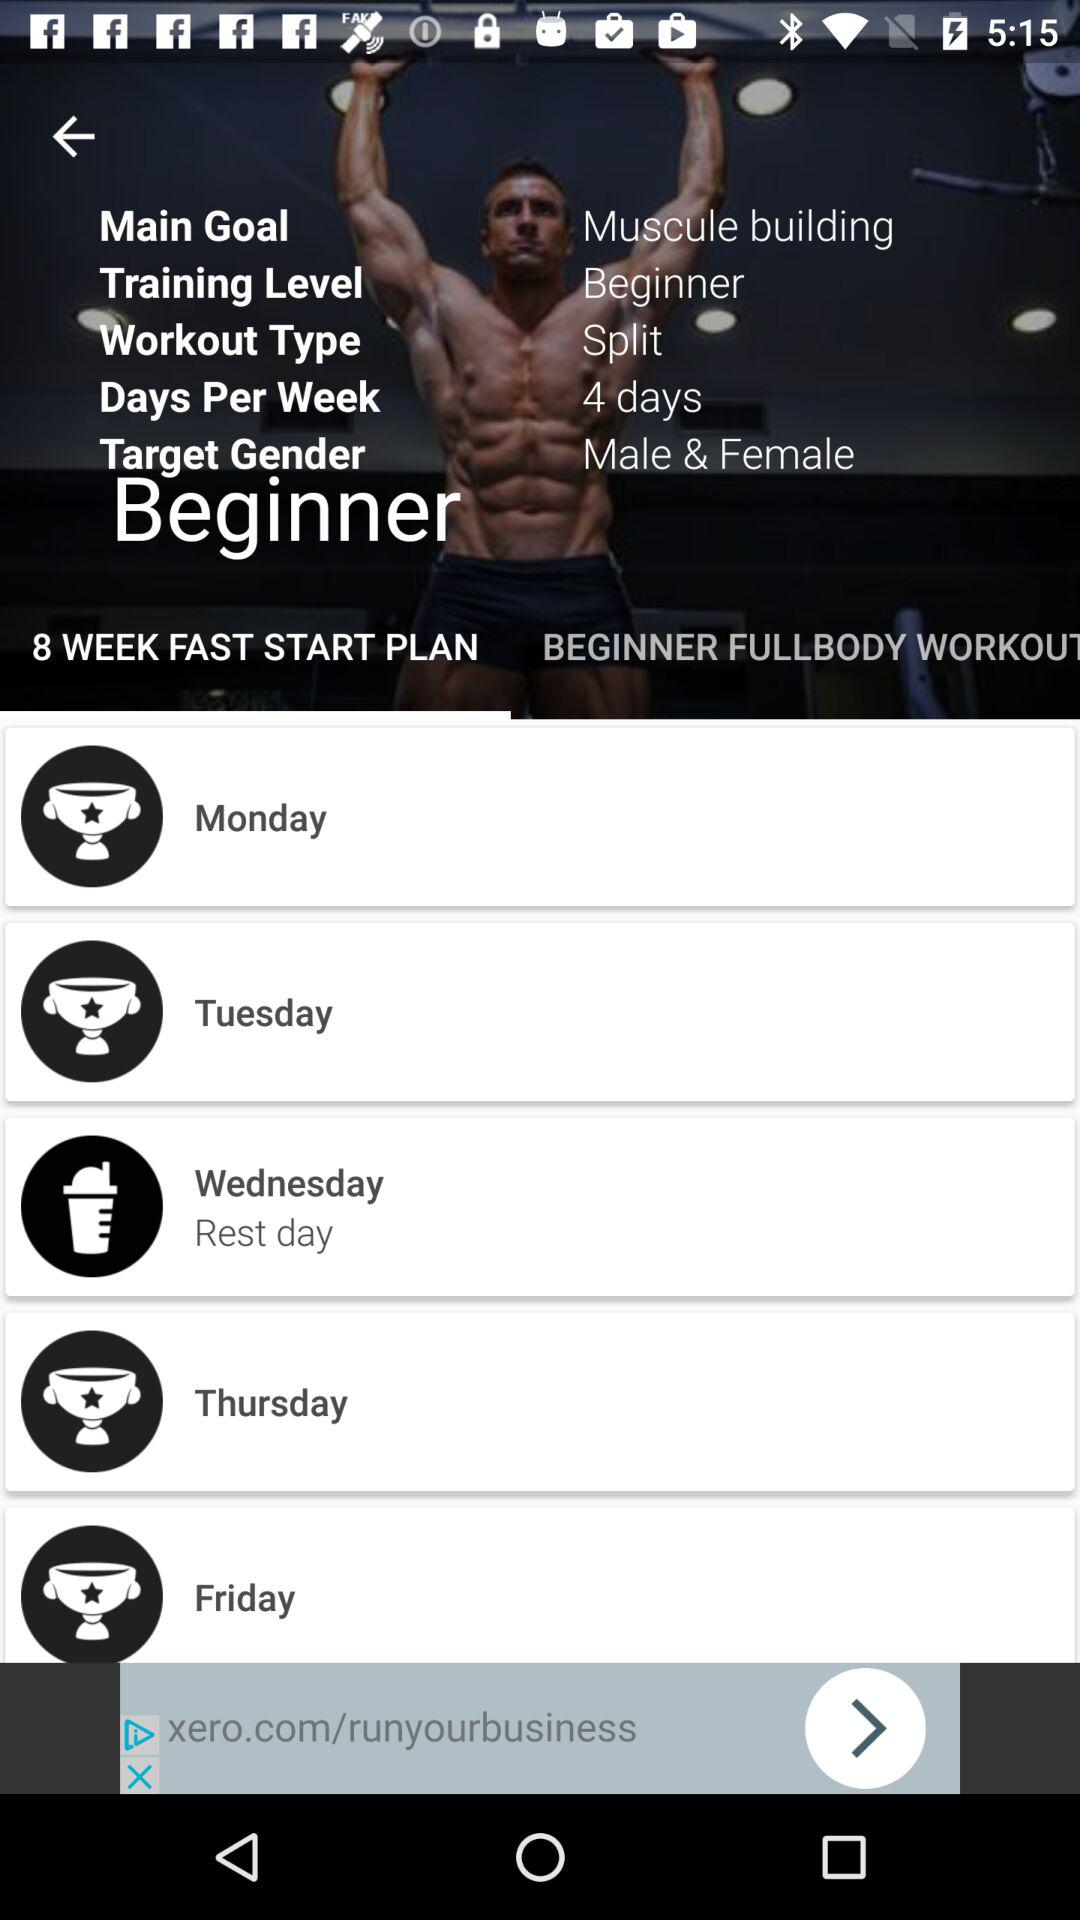For how many weeks is the fast start plan? The fast start plan is for 8 weeks. 